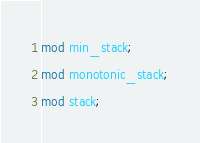<code> <loc_0><loc_0><loc_500><loc_500><_Rust_>mod min_stack;
mod monotonic_stack;
mod stack;
</code> 